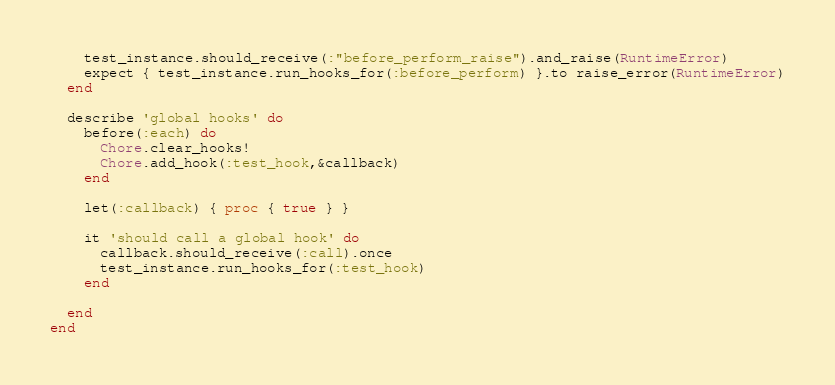<code> <loc_0><loc_0><loc_500><loc_500><_Ruby_>    test_instance.should_receive(:"before_perform_raise").and_raise(RuntimeError)
    expect { test_instance.run_hooks_for(:before_perform) }.to raise_error(RuntimeError)
  end

  describe 'global hooks' do
    before(:each) do
      Chore.clear_hooks!
      Chore.add_hook(:test_hook,&callback)
    end

    let(:callback) { proc { true } }

    it 'should call a global hook' do
      callback.should_receive(:call).once
      test_instance.run_hooks_for(:test_hook)
    end

  end
end
</code> 